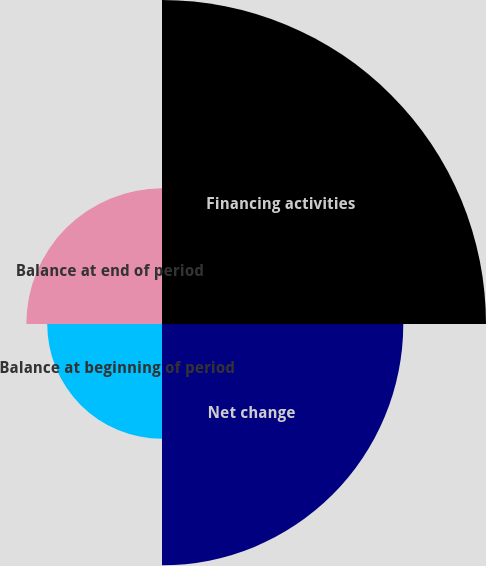<chart> <loc_0><loc_0><loc_500><loc_500><pie_chart><fcel>Financing activities<fcel>Net change<fcel>Balance at beginning of period<fcel>Balance at end of period<nl><fcel>39.72%<fcel>29.58%<fcel>14.07%<fcel>16.63%<nl></chart> 